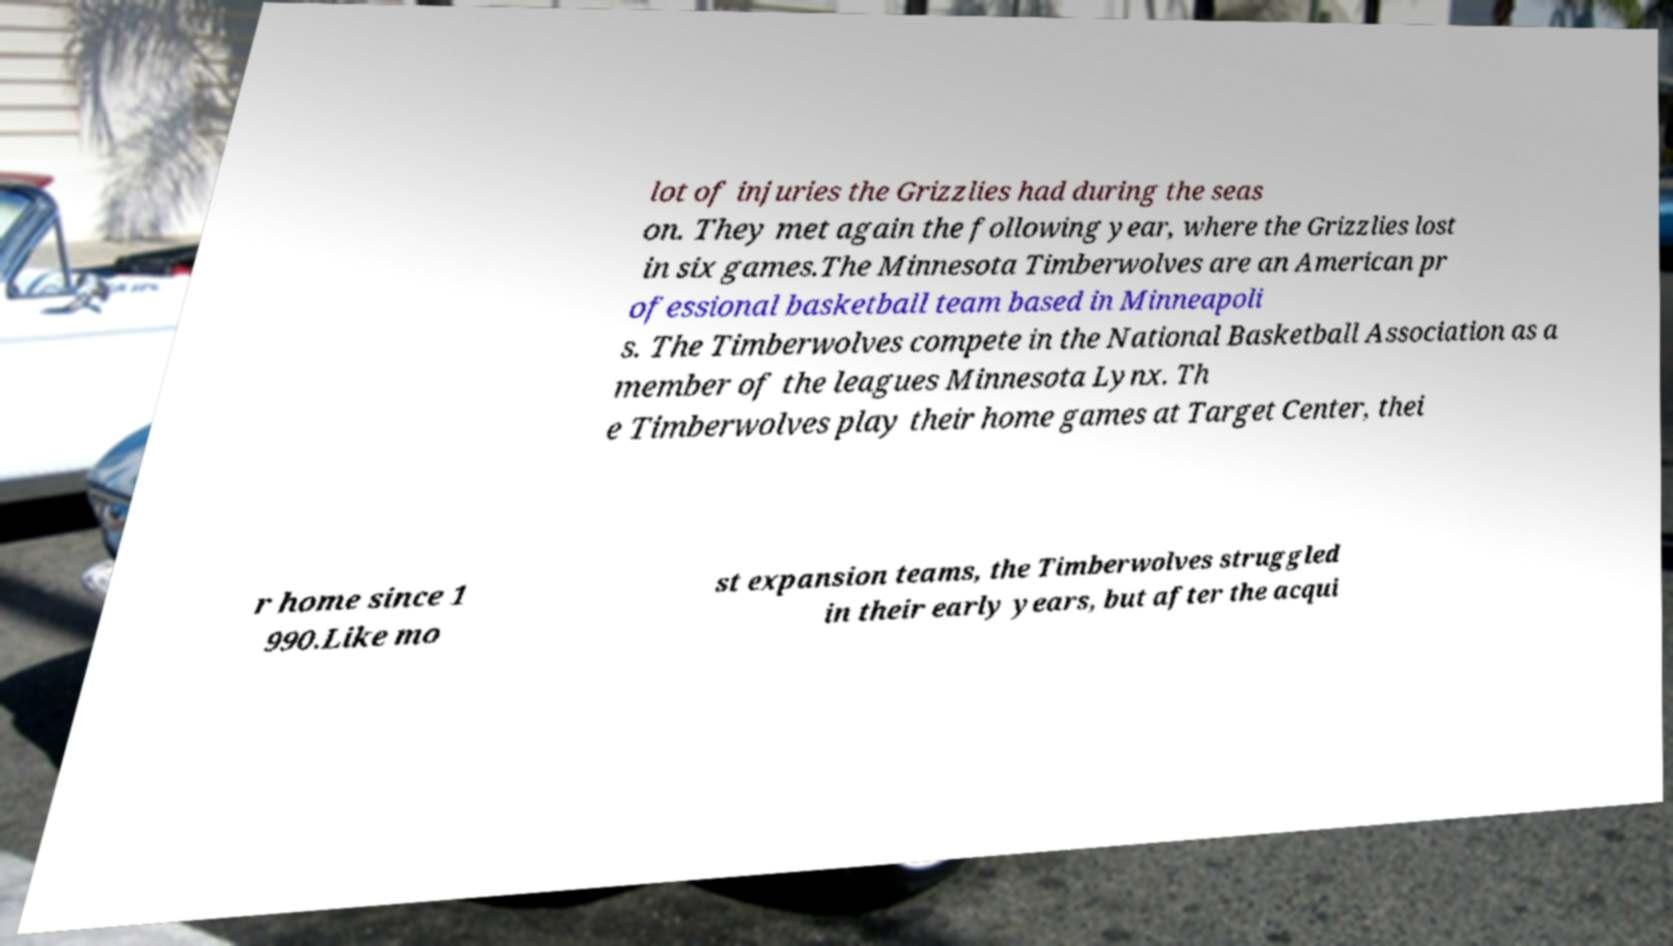I need the written content from this picture converted into text. Can you do that? lot of injuries the Grizzlies had during the seas on. They met again the following year, where the Grizzlies lost in six games.The Minnesota Timberwolves are an American pr ofessional basketball team based in Minneapoli s. The Timberwolves compete in the National Basketball Association as a member of the leagues Minnesota Lynx. Th e Timberwolves play their home games at Target Center, thei r home since 1 990.Like mo st expansion teams, the Timberwolves struggled in their early years, but after the acqui 